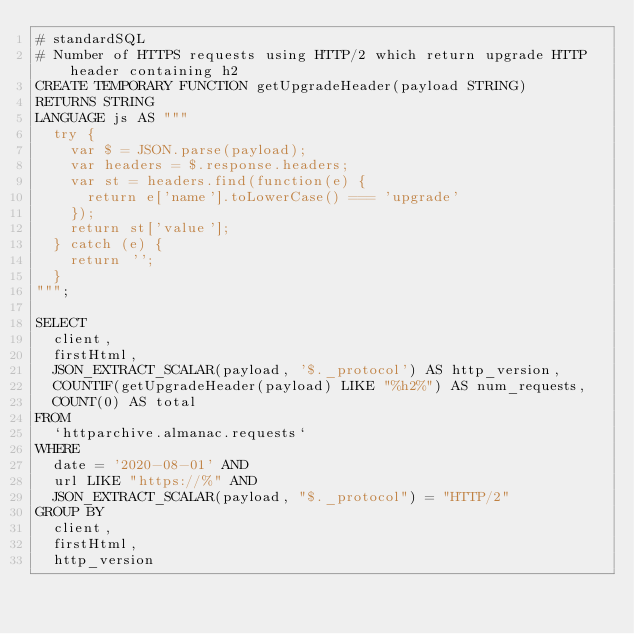<code> <loc_0><loc_0><loc_500><loc_500><_SQL_># standardSQL
# Number of HTTPS requests using HTTP/2 which return upgrade HTTP header containing h2
CREATE TEMPORARY FUNCTION getUpgradeHeader(payload STRING)
RETURNS STRING
LANGUAGE js AS """
  try {
    var $ = JSON.parse(payload);
    var headers = $.response.headers;
    var st = headers.find(function(e) {
      return e['name'].toLowerCase() === 'upgrade'
    });
    return st['value'];
  } catch (e) {
    return '';
  }
""";

SELECT
  client,
  firstHtml,
  JSON_EXTRACT_SCALAR(payload, '$._protocol') AS http_version,
  COUNTIF(getUpgradeHeader(payload) LIKE "%h2%") AS num_requests,
  COUNT(0) AS total
FROM
  `httparchive.almanac.requests`
WHERE
  date = '2020-08-01' AND
  url LIKE "https://%" AND
  JSON_EXTRACT_SCALAR(payload, "$._protocol") = "HTTP/2"
GROUP BY
  client,
  firstHtml,
  http_version
</code> 